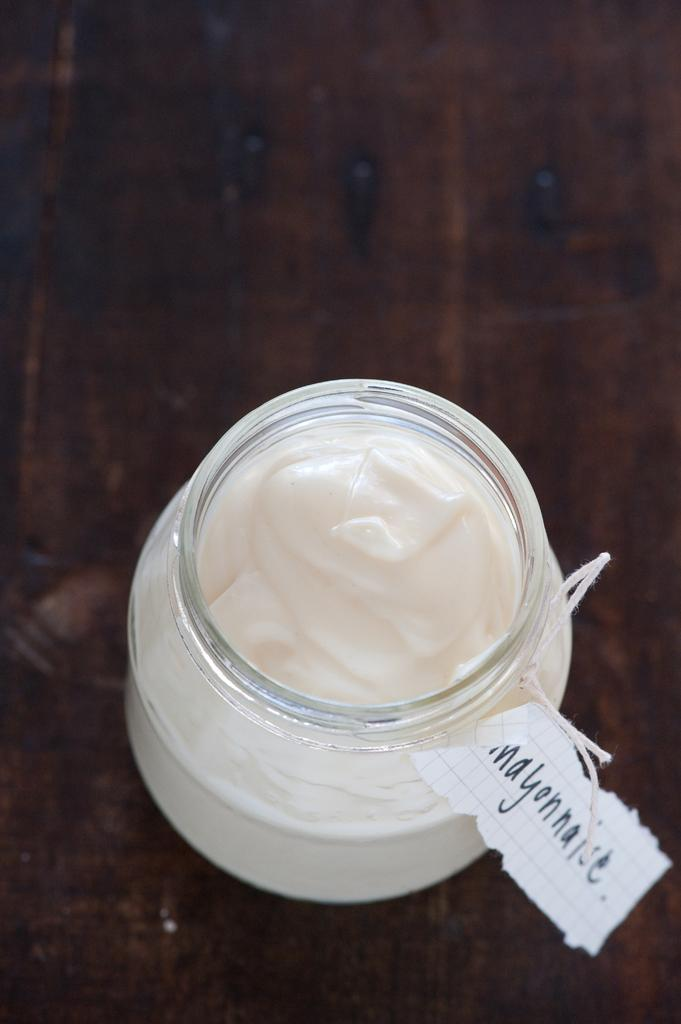<image>
Share a concise interpretation of the image provided. a jar full of mayonnaise inside of it 